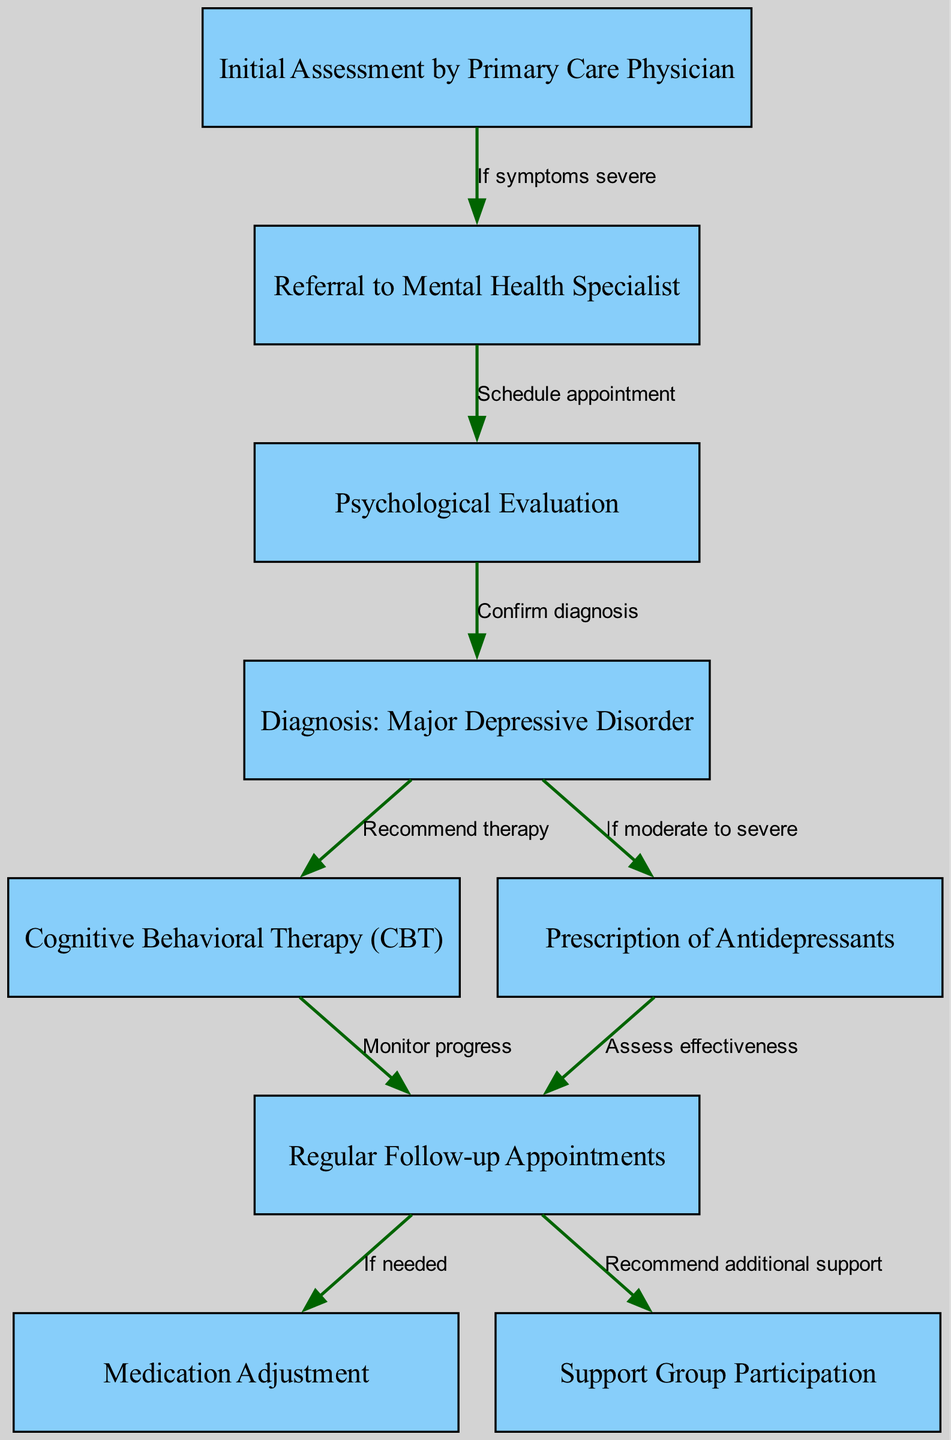What is the first step in the mental health treatment pathway? The diagram indicates that the first step is "Initial Assessment by Primary Care Physician." This is the starting point for all patients entering the mental health treatment pathway.
Answer: Initial Assessment by Primary Care Physician What is the condition diagnosed if the psychological evaluation is confirmed? According to the diagram, the outcome of confirming the psychological evaluation is a diagnosis of "Major Depressive Disorder." This node directly follows the psychological evaluation node.
Answer: Major Depressive Disorder How many nodes are present in the diagram? By counting all the unique nodes in the diagram, we find that there are nine nodes in total, representing different steps and evaluations in the treatment pathway.
Answer: 9 What type of therapy is recommended after confirming a major depressive disorder diagnosis? The diagram indicates that "Cognitive Behavioral Therapy (CBT)" is the recommended therapy following the diagnosis of major depressive disorder. This node is directly connected to the diagnosis node.
Answer: Cognitive Behavioral Therapy (CBT) How does the pathway indicate medication management following regular appointments? The diagram shows that regular follow-up appointments lead to "Medication Adjustment" if needed. This implies that the pathway allows for reassessment of medication based on the patient's ongoing status.
Answer: Medication Adjustment If symptoms are severe at the initial assessment, what is the next action? Based on the diagram, if symptoms are severe, the next action is "Referral to Mental Health Specialist." This is outlined as the resulting step from the initial assessment node.
Answer: Referral to Mental Health Specialist What additional support is recommended alongside regular appointments? The diagram specifies that "Support Group Participation" is recommended as an additional support mechanism alongside regular follow-up appointments. This indicates the comprehensive care approach for the patients.
Answer: Support Group Participation What is the relationship between the diagnosis and therapy in this pathway? The relationship indicated in the diagram shows that a diagnosis of major depressive disorder leads directly to the recommendation of cognitive behavioral therapy (CBT). This reflects the pathway's logical flow from diagnosis to treatment.
Answer: Recommend therapy What action is taken if the effectiveness of the antidepressants is assessed during follow-up? If the effectiveness of the antidepressants is assessed during follow-up appointments, the action taken is "Medication Adjustment." This signifies a responsive approach to treatment based on ongoing evaluation.
Answer: Medication Adjustment 